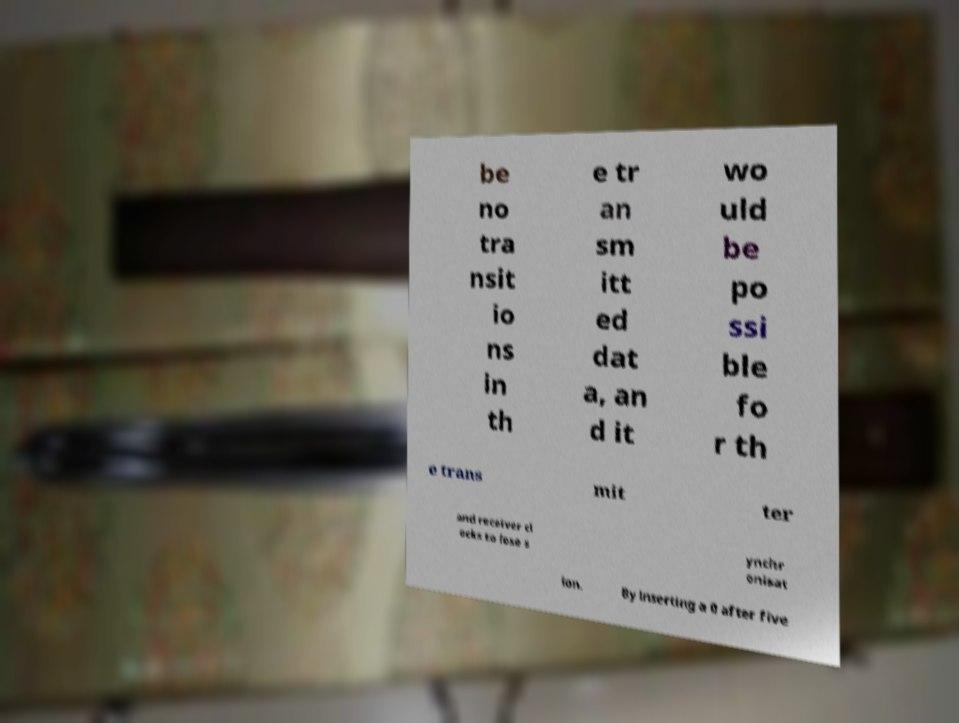There's text embedded in this image that I need extracted. Can you transcribe it verbatim? be no tra nsit io ns in th e tr an sm itt ed dat a, an d it wo uld be po ssi ble fo r th e trans mit ter and receiver cl ocks to lose s ynchr onisat ion. By inserting a 0 after five 